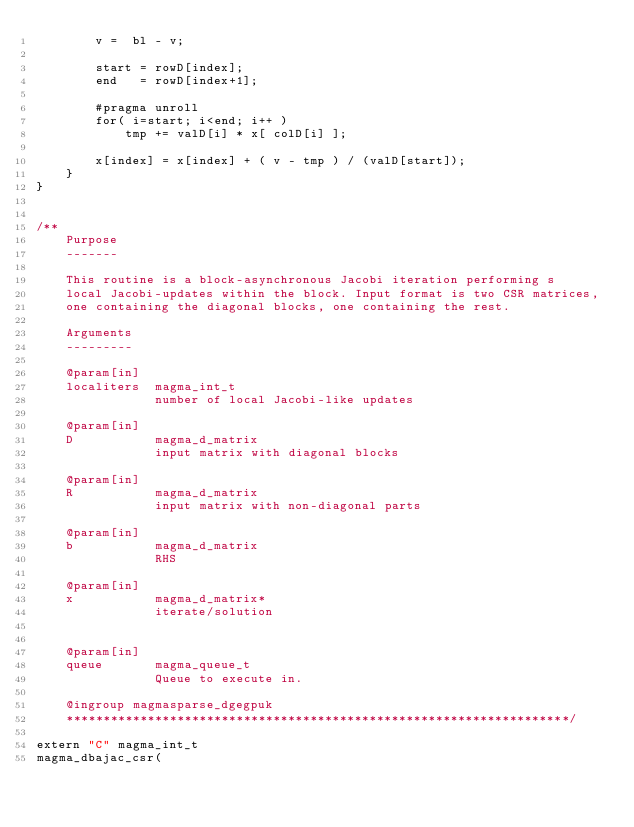Convert code to text. <code><loc_0><loc_0><loc_500><loc_500><_Cuda_>        v =  bl - v;

        start = rowD[index];
        end   = rowD[index+1];

        #pragma unroll
        for( i=start; i<end; i++ )
            tmp += valD[i] * x[ colD[i] ];

        x[index] = x[index] + ( v - tmp ) / (valD[start]); 
    }
}


/**
    Purpose
    -------
    
    This routine is a block-asynchronous Jacobi iteration performing s
    local Jacobi-updates within the block. Input format is two CSR matrices,
    one containing the diagonal blocks, one containing the rest.

    Arguments
    ---------

    @param[in]
    localiters  magma_int_t
                number of local Jacobi-like updates

    @param[in]
    D           magma_d_matrix
                input matrix with diagonal blocks

    @param[in]
    R           magma_d_matrix
                input matrix with non-diagonal parts

    @param[in]
    b           magma_d_matrix
                RHS

    @param[in]
    x           magma_d_matrix*
                iterate/solution

    
    @param[in]
    queue       magma_queue_t
                Queue to execute in.

    @ingroup magmasparse_dgegpuk
    ********************************************************************/

extern "C" magma_int_t
magma_dbajac_csr(</code> 